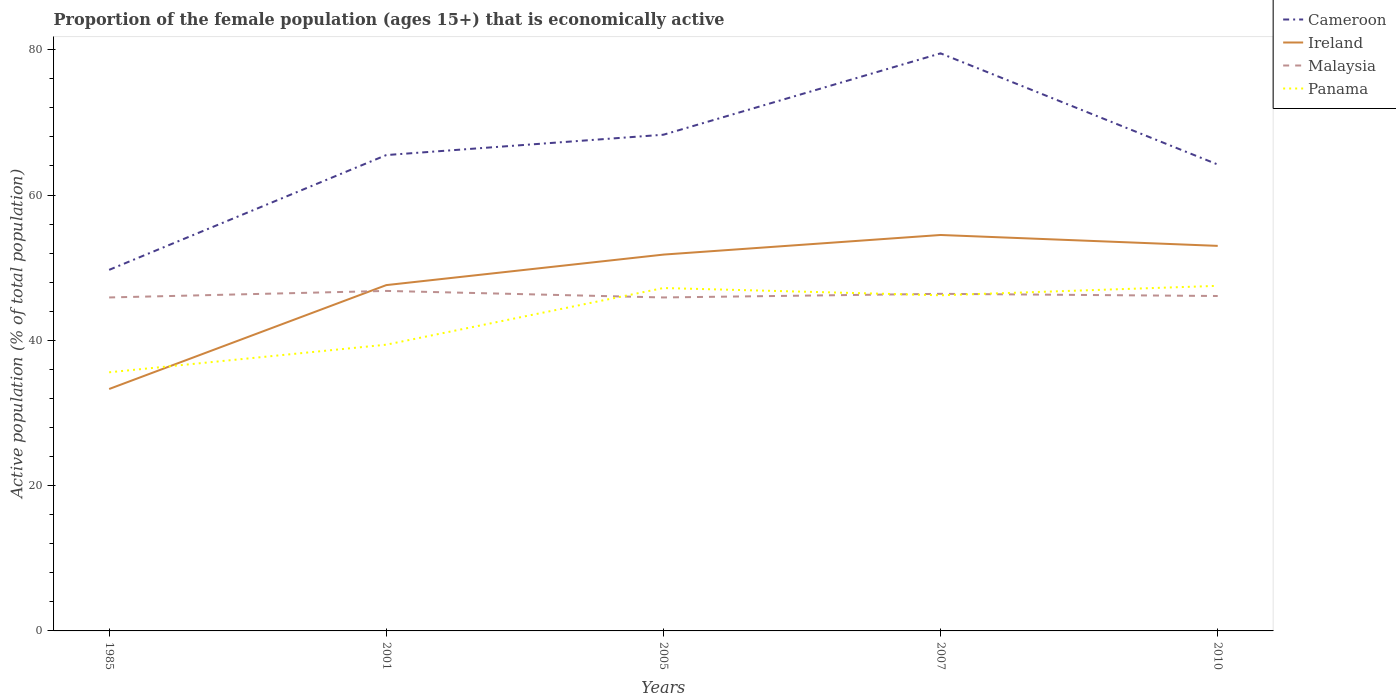How many different coloured lines are there?
Your answer should be compact. 4. Across all years, what is the maximum proportion of the female population that is economically active in Cameroon?
Offer a very short reply. 49.7. In which year was the proportion of the female population that is economically active in Ireland maximum?
Your answer should be very brief. 1985. What is the total proportion of the female population that is economically active in Panama in the graph?
Your answer should be very brief. 1. What is the difference between the highest and the second highest proportion of the female population that is economically active in Malaysia?
Offer a terse response. 0.9. What is the difference between the highest and the lowest proportion of the female population that is economically active in Malaysia?
Offer a very short reply. 2. Is the proportion of the female population that is economically active in Cameroon strictly greater than the proportion of the female population that is economically active in Malaysia over the years?
Offer a very short reply. No. How many lines are there?
Make the answer very short. 4. Does the graph contain grids?
Provide a succinct answer. No. Where does the legend appear in the graph?
Offer a terse response. Top right. How many legend labels are there?
Your answer should be compact. 4. What is the title of the graph?
Provide a succinct answer. Proportion of the female population (ages 15+) that is economically active. What is the label or title of the Y-axis?
Your answer should be compact. Active population (% of total population). What is the Active population (% of total population) of Cameroon in 1985?
Provide a succinct answer. 49.7. What is the Active population (% of total population) of Ireland in 1985?
Make the answer very short. 33.3. What is the Active population (% of total population) of Malaysia in 1985?
Give a very brief answer. 45.9. What is the Active population (% of total population) of Panama in 1985?
Offer a terse response. 35.6. What is the Active population (% of total population) in Cameroon in 2001?
Make the answer very short. 65.5. What is the Active population (% of total population) of Ireland in 2001?
Your answer should be compact. 47.6. What is the Active population (% of total population) in Malaysia in 2001?
Provide a short and direct response. 46.8. What is the Active population (% of total population) in Panama in 2001?
Offer a very short reply. 39.4. What is the Active population (% of total population) in Cameroon in 2005?
Keep it short and to the point. 68.3. What is the Active population (% of total population) of Ireland in 2005?
Your answer should be very brief. 51.8. What is the Active population (% of total population) in Malaysia in 2005?
Provide a succinct answer. 45.9. What is the Active population (% of total population) of Panama in 2005?
Offer a terse response. 47.2. What is the Active population (% of total population) in Cameroon in 2007?
Provide a short and direct response. 79.5. What is the Active population (% of total population) of Ireland in 2007?
Offer a very short reply. 54.5. What is the Active population (% of total population) in Malaysia in 2007?
Your response must be concise. 46.4. What is the Active population (% of total population) of Panama in 2007?
Offer a very short reply. 46.2. What is the Active population (% of total population) of Cameroon in 2010?
Your answer should be very brief. 64.2. What is the Active population (% of total population) of Ireland in 2010?
Ensure brevity in your answer.  53. What is the Active population (% of total population) in Malaysia in 2010?
Give a very brief answer. 46.1. What is the Active population (% of total population) of Panama in 2010?
Provide a succinct answer. 47.5. Across all years, what is the maximum Active population (% of total population) of Cameroon?
Provide a succinct answer. 79.5. Across all years, what is the maximum Active population (% of total population) in Ireland?
Offer a terse response. 54.5. Across all years, what is the maximum Active population (% of total population) in Malaysia?
Your response must be concise. 46.8. Across all years, what is the maximum Active population (% of total population) in Panama?
Offer a terse response. 47.5. Across all years, what is the minimum Active population (% of total population) in Cameroon?
Your response must be concise. 49.7. Across all years, what is the minimum Active population (% of total population) in Ireland?
Ensure brevity in your answer.  33.3. Across all years, what is the minimum Active population (% of total population) of Malaysia?
Make the answer very short. 45.9. Across all years, what is the minimum Active population (% of total population) in Panama?
Provide a succinct answer. 35.6. What is the total Active population (% of total population) of Cameroon in the graph?
Offer a terse response. 327.2. What is the total Active population (% of total population) in Ireland in the graph?
Give a very brief answer. 240.2. What is the total Active population (% of total population) of Malaysia in the graph?
Offer a terse response. 231.1. What is the total Active population (% of total population) in Panama in the graph?
Give a very brief answer. 215.9. What is the difference between the Active population (% of total population) of Cameroon in 1985 and that in 2001?
Keep it short and to the point. -15.8. What is the difference between the Active population (% of total population) of Ireland in 1985 and that in 2001?
Give a very brief answer. -14.3. What is the difference between the Active population (% of total population) in Cameroon in 1985 and that in 2005?
Your response must be concise. -18.6. What is the difference between the Active population (% of total population) of Ireland in 1985 and that in 2005?
Make the answer very short. -18.5. What is the difference between the Active population (% of total population) in Panama in 1985 and that in 2005?
Make the answer very short. -11.6. What is the difference between the Active population (% of total population) of Cameroon in 1985 and that in 2007?
Your answer should be compact. -29.8. What is the difference between the Active population (% of total population) of Ireland in 1985 and that in 2007?
Your answer should be compact. -21.2. What is the difference between the Active population (% of total population) in Panama in 1985 and that in 2007?
Make the answer very short. -10.6. What is the difference between the Active population (% of total population) in Ireland in 1985 and that in 2010?
Provide a short and direct response. -19.7. What is the difference between the Active population (% of total population) in Panama in 1985 and that in 2010?
Offer a terse response. -11.9. What is the difference between the Active population (% of total population) in Cameroon in 2001 and that in 2005?
Provide a succinct answer. -2.8. What is the difference between the Active population (% of total population) of Ireland in 2001 and that in 2005?
Keep it short and to the point. -4.2. What is the difference between the Active population (% of total population) in Malaysia in 2001 and that in 2005?
Your answer should be very brief. 0.9. What is the difference between the Active population (% of total population) of Panama in 2001 and that in 2005?
Make the answer very short. -7.8. What is the difference between the Active population (% of total population) of Cameroon in 2001 and that in 2007?
Provide a short and direct response. -14. What is the difference between the Active population (% of total population) of Malaysia in 2001 and that in 2007?
Your answer should be very brief. 0.4. What is the difference between the Active population (% of total population) in Cameroon in 2001 and that in 2010?
Keep it short and to the point. 1.3. What is the difference between the Active population (% of total population) in Malaysia in 2001 and that in 2010?
Ensure brevity in your answer.  0.7. What is the difference between the Active population (% of total population) of Panama in 2001 and that in 2010?
Provide a succinct answer. -8.1. What is the difference between the Active population (% of total population) of Panama in 2005 and that in 2007?
Provide a short and direct response. 1. What is the difference between the Active population (% of total population) in Cameroon in 2005 and that in 2010?
Give a very brief answer. 4.1. What is the difference between the Active population (% of total population) in Panama in 2005 and that in 2010?
Keep it short and to the point. -0.3. What is the difference between the Active population (% of total population) in Panama in 2007 and that in 2010?
Make the answer very short. -1.3. What is the difference between the Active population (% of total population) of Cameroon in 1985 and the Active population (% of total population) of Panama in 2001?
Give a very brief answer. 10.3. What is the difference between the Active population (% of total population) of Ireland in 1985 and the Active population (% of total population) of Panama in 2001?
Your response must be concise. -6.1. What is the difference between the Active population (% of total population) in Malaysia in 1985 and the Active population (% of total population) in Panama in 2001?
Give a very brief answer. 6.5. What is the difference between the Active population (% of total population) of Cameroon in 1985 and the Active population (% of total population) of Malaysia in 2005?
Keep it short and to the point. 3.8. What is the difference between the Active population (% of total population) of Cameroon in 1985 and the Active population (% of total population) of Panama in 2007?
Provide a succinct answer. 3.5. What is the difference between the Active population (% of total population) of Ireland in 1985 and the Active population (% of total population) of Malaysia in 2007?
Make the answer very short. -13.1. What is the difference between the Active population (% of total population) of Ireland in 1985 and the Active population (% of total population) of Panama in 2007?
Provide a succinct answer. -12.9. What is the difference between the Active population (% of total population) in Cameroon in 1985 and the Active population (% of total population) in Ireland in 2010?
Offer a very short reply. -3.3. What is the difference between the Active population (% of total population) of Cameroon in 1985 and the Active population (% of total population) of Malaysia in 2010?
Keep it short and to the point. 3.6. What is the difference between the Active population (% of total population) of Cameroon in 1985 and the Active population (% of total population) of Panama in 2010?
Your answer should be very brief. 2.2. What is the difference between the Active population (% of total population) in Ireland in 1985 and the Active population (% of total population) in Panama in 2010?
Your response must be concise. -14.2. What is the difference between the Active population (% of total population) in Cameroon in 2001 and the Active population (% of total population) in Ireland in 2005?
Provide a short and direct response. 13.7. What is the difference between the Active population (% of total population) in Cameroon in 2001 and the Active population (% of total population) in Malaysia in 2005?
Ensure brevity in your answer.  19.6. What is the difference between the Active population (% of total population) in Cameroon in 2001 and the Active population (% of total population) in Panama in 2005?
Ensure brevity in your answer.  18.3. What is the difference between the Active population (% of total population) in Ireland in 2001 and the Active population (% of total population) in Malaysia in 2005?
Your answer should be very brief. 1.7. What is the difference between the Active population (% of total population) in Ireland in 2001 and the Active population (% of total population) in Panama in 2005?
Ensure brevity in your answer.  0.4. What is the difference between the Active population (% of total population) in Malaysia in 2001 and the Active population (% of total population) in Panama in 2005?
Keep it short and to the point. -0.4. What is the difference between the Active population (% of total population) in Cameroon in 2001 and the Active population (% of total population) in Malaysia in 2007?
Provide a short and direct response. 19.1. What is the difference between the Active population (% of total population) in Cameroon in 2001 and the Active population (% of total population) in Panama in 2007?
Your response must be concise. 19.3. What is the difference between the Active population (% of total population) of Ireland in 2001 and the Active population (% of total population) of Panama in 2007?
Your answer should be compact. 1.4. What is the difference between the Active population (% of total population) of Cameroon in 2001 and the Active population (% of total population) of Panama in 2010?
Your answer should be very brief. 18. What is the difference between the Active population (% of total population) in Ireland in 2001 and the Active population (% of total population) in Panama in 2010?
Provide a short and direct response. 0.1. What is the difference between the Active population (% of total population) in Cameroon in 2005 and the Active population (% of total population) in Malaysia in 2007?
Make the answer very short. 21.9. What is the difference between the Active population (% of total population) of Cameroon in 2005 and the Active population (% of total population) of Panama in 2007?
Offer a very short reply. 22.1. What is the difference between the Active population (% of total population) in Ireland in 2005 and the Active population (% of total population) in Panama in 2007?
Offer a terse response. 5.6. What is the difference between the Active population (% of total population) of Cameroon in 2005 and the Active population (% of total population) of Ireland in 2010?
Keep it short and to the point. 15.3. What is the difference between the Active population (% of total population) in Cameroon in 2005 and the Active population (% of total population) in Panama in 2010?
Your answer should be very brief. 20.8. What is the difference between the Active population (% of total population) in Ireland in 2005 and the Active population (% of total population) in Malaysia in 2010?
Offer a terse response. 5.7. What is the difference between the Active population (% of total population) of Ireland in 2005 and the Active population (% of total population) of Panama in 2010?
Your answer should be compact. 4.3. What is the difference between the Active population (% of total population) in Cameroon in 2007 and the Active population (% of total population) in Ireland in 2010?
Offer a very short reply. 26.5. What is the difference between the Active population (% of total population) in Cameroon in 2007 and the Active population (% of total population) in Malaysia in 2010?
Offer a very short reply. 33.4. What is the difference between the Active population (% of total population) in Ireland in 2007 and the Active population (% of total population) in Panama in 2010?
Provide a succinct answer. 7. What is the difference between the Active population (% of total population) in Malaysia in 2007 and the Active population (% of total population) in Panama in 2010?
Keep it short and to the point. -1.1. What is the average Active population (% of total population) in Cameroon per year?
Ensure brevity in your answer.  65.44. What is the average Active population (% of total population) of Ireland per year?
Give a very brief answer. 48.04. What is the average Active population (% of total population) in Malaysia per year?
Your response must be concise. 46.22. What is the average Active population (% of total population) of Panama per year?
Make the answer very short. 43.18. In the year 1985, what is the difference between the Active population (% of total population) of Cameroon and Active population (% of total population) of Ireland?
Make the answer very short. 16.4. In the year 1985, what is the difference between the Active population (% of total population) of Cameroon and Active population (% of total population) of Malaysia?
Your answer should be very brief. 3.8. In the year 1985, what is the difference between the Active population (% of total population) in Ireland and Active population (% of total population) in Malaysia?
Offer a very short reply. -12.6. In the year 1985, what is the difference between the Active population (% of total population) in Malaysia and Active population (% of total population) in Panama?
Offer a terse response. 10.3. In the year 2001, what is the difference between the Active population (% of total population) of Cameroon and Active population (% of total population) of Ireland?
Ensure brevity in your answer.  17.9. In the year 2001, what is the difference between the Active population (% of total population) in Cameroon and Active population (% of total population) in Panama?
Provide a short and direct response. 26.1. In the year 2001, what is the difference between the Active population (% of total population) of Ireland and Active population (% of total population) of Malaysia?
Provide a short and direct response. 0.8. In the year 2001, what is the difference between the Active population (% of total population) in Ireland and Active population (% of total population) in Panama?
Provide a short and direct response. 8.2. In the year 2001, what is the difference between the Active population (% of total population) in Malaysia and Active population (% of total population) in Panama?
Provide a short and direct response. 7.4. In the year 2005, what is the difference between the Active population (% of total population) of Cameroon and Active population (% of total population) of Ireland?
Make the answer very short. 16.5. In the year 2005, what is the difference between the Active population (% of total population) of Cameroon and Active population (% of total population) of Malaysia?
Keep it short and to the point. 22.4. In the year 2005, what is the difference between the Active population (% of total population) in Cameroon and Active population (% of total population) in Panama?
Give a very brief answer. 21.1. In the year 2007, what is the difference between the Active population (% of total population) in Cameroon and Active population (% of total population) in Ireland?
Offer a very short reply. 25. In the year 2007, what is the difference between the Active population (% of total population) in Cameroon and Active population (% of total population) in Malaysia?
Your response must be concise. 33.1. In the year 2007, what is the difference between the Active population (% of total population) in Cameroon and Active population (% of total population) in Panama?
Make the answer very short. 33.3. In the year 2007, what is the difference between the Active population (% of total population) in Ireland and Active population (% of total population) in Malaysia?
Provide a short and direct response. 8.1. In the year 2007, what is the difference between the Active population (% of total population) of Ireland and Active population (% of total population) of Panama?
Offer a very short reply. 8.3. In the year 2010, what is the difference between the Active population (% of total population) in Cameroon and Active population (% of total population) in Ireland?
Your answer should be compact. 11.2. In the year 2010, what is the difference between the Active population (% of total population) in Cameroon and Active population (% of total population) in Malaysia?
Provide a short and direct response. 18.1. In the year 2010, what is the difference between the Active population (% of total population) of Cameroon and Active population (% of total population) of Panama?
Offer a terse response. 16.7. In the year 2010, what is the difference between the Active population (% of total population) in Ireland and Active population (% of total population) in Malaysia?
Provide a short and direct response. 6.9. In the year 2010, what is the difference between the Active population (% of total population) of Ireland and Active population (% of total population) of Panama?
Ensure brevity in your answer.  5.5. In the year 2010, what is the difference between the Active population (% of total population) in Malaysia and Active population (% of total population) in Panama?
Make the answer very short. -1.4. What is the ratio of the Active population (% of total population) in Cameroon in 1985 to that in 2001?
Keep it short and to the point. 0.76. What is the ratio of the Active population (% of total population) in Ireland in 1985 to that in 2001?
Keep it short and to the point. 0.7. What is the ratio of the Active population (% of total population) of Malaysia in 1985 to that in 2001?
Offer a very short reply. 0.98. What is the ratio of the Active population (% of total population) of Panama in 1985 to that in 2001?
Your response must be concise. 0.9. What is the ratio of the Active population (% of total population) of Cameroon in 1985 to that in 2005?
Your answer should be very brief. 0.73. What is the ratio of the Active population (% of total population) in Ireland in 1985 to that in 2005?
Your answer should be compact. 0.64. What is the ratio of the Active population (% of total population) of Panama in 1985 to that in 2005?
Provide a short and direct response. 0.75. What is the ratio of the Active population (% of total population) of Cameroon in 1985 to that in 2007?
Ensure brevity in your answer.  0.63. What is the ratio of the Active population (% of total population) of Ireland in 1985 to that in 2007?
Ensure brevity in your answer.  0.61. What is the ratio of the Active population (% of total population) of Malaysia in 1985 to that in 2007?
Give a very brief answer. 0.99. What is the ratio of the Active population (% of total population) of Panama in 1985 to that in 2007?
Ensure brevity in your answer.  0.77. What is the ratio of the Active population (% of total population) in Cameroon in 1985 to that in 2010?
Give a very brief answer. 0.77. What is the ratio of the Active population (% of total population) in Ireland in 1985 to that in 2010?
Keep it short and to the point. 0.63. What is the ratio of the Active population (% of total population) in Panama in 1985 to that in 2010?
Make the answer very short. 0.75. What is the ratio of the Active population (% of total population) in Ireland in 2001 to that in 2005?
Your answer should be very brief. 0.92. What is the ratio of the Active population (% of total population) of Malaysia in 2001 to that in 2005?
Make the answer very short. 1.02. What is the ratio of the Active population (% of total population) in Panama in 2001 to that in 2005?
Keep it short and to the point. 0.83. What is the ratio of the Active population (% of total population) in Cameroon in 2001 to that in 2007?
Ensure brevity in your answer.  0.82. What is the ratio of the Active population (% of total population) in Ireland in 2001 to that in 2007?
Your answer should be compact. 0.87. What is the ratio of the Active population (% of total population) of Malaysia in 2001 to that in 2007?
Provide a succinct answer. 1.01. What is the ratio of the Active population (% of total population) in Panama in 2001 to that in 2007?
Keep it short and to the point. 0.85. What is the ratio of the Active population (% of total population) of Cameroon in 2001 to that in 2010?
Offer a very short reply. 1.02. What is the ratio of the Active population (% of total population) of Ireland in 2001 to that in 2010?
Ensure brevity in your answer.  0.9. What is the ratio of the Active population (% of total population) in Malaysia in 2001 to that in 2010?
Ensure brevity in your answer.  1.02. What is the ratio of the Active population (% of total population) in Panama in 2001 to that in 2010?
Your answer should be compact. 0.83. What is the ratio of the Active population (% of total population) of Cameroon in 2005 to that in 2007?
Provide a succinct answer. 0.86. What is the ratio of the Active population (% of total population) of Ireland in 2005 to that in 2007?
Offer a terse response. 0.95. What is the ratio of the Active population (% of total population) in Panama in 2005 to that in 2007?
Offer a terse response. 1.02. What is the ratio of the Active population (% of total population) of Cameroon in 2005 to that in 2010?
Your response must be concise. 1.06. What is the ratio of the Active population (% of total population) of Ireland in 2005 to that in 2010?
Offer a terse response. 0.98. What is the ratio of the Active population (% of total population) in Cameroon in 2007 to that in 2010?
Your answer should be very brief. 1.24. What is the ratio of the Active population (% of total population) in Ireland in 2007 to that in 2010?
Make the answer very short. 1.03. What is the ratio of the Active population (% of total population) of Malaysia in 2007 to that in 2010?
Provide a short and direct response. 1.01. What is the ratio of the Active population (% of total population) of Panama in 2007 to that in 2010?
Provide a succinct answer. 0.97. What is the difference between the highest and the second highest Active population (% of total population) of Ireland?
Your response must be concise. 1.5. What is the difference between the highest and the second highest Active population (% of total population) of Malaysia?
Keep it short and to the point. 0.4. What is the difference between the highest and the second highest Active population (% of total population) in Panama?
Your answer should be very brief. 0.3. What is the difference between the highest and the lowest Active population (% of total population) in Cameroon?
Offer a terse response. 29.8. What is the difference between the highest and the lowest Active population (% of total population) of Ireland?
Your response must be concise. 21.2. What is the difference between the highest and the lowest Active population (% of total population) in Malaysia?
Your answer should be very brief. 0.9. 